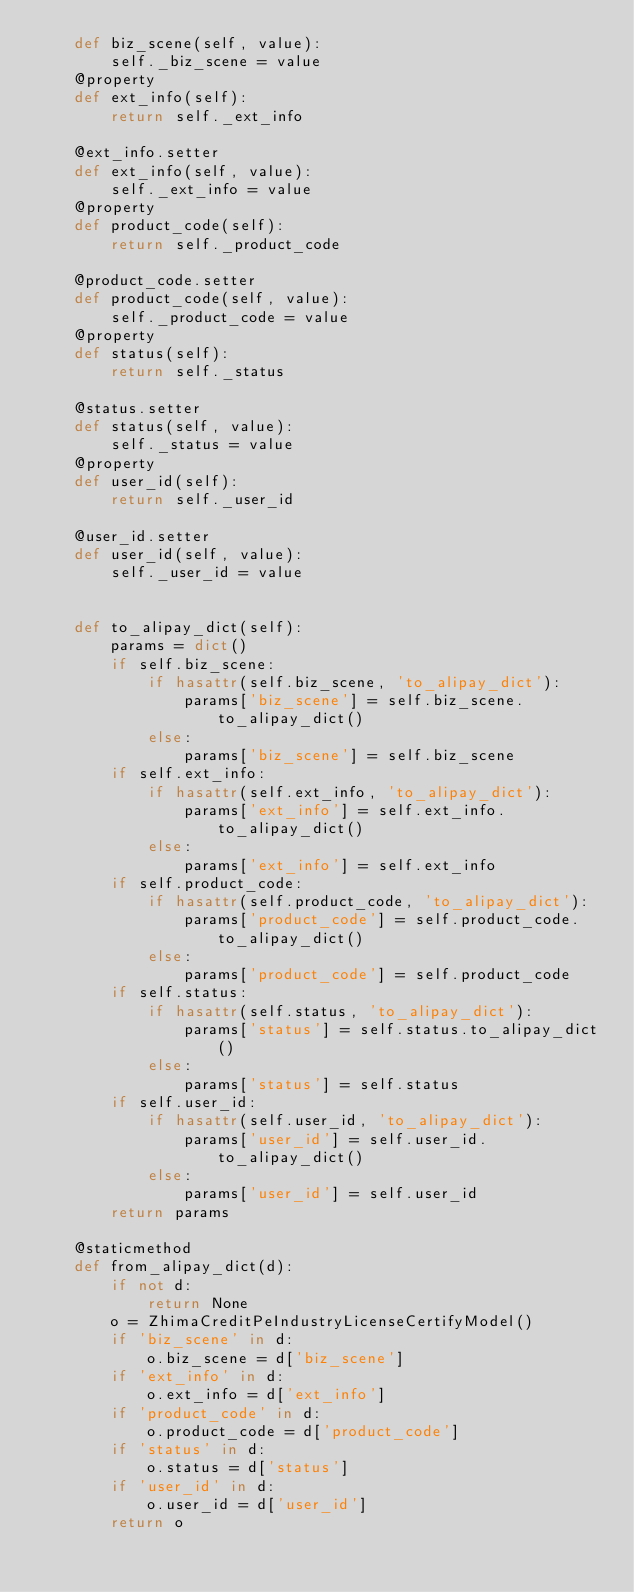Convert code to text. <code><loc_0><loc_0><loc_500><loc_500><_Python_>    def biz_scene(self, value):
        self._biz_scene = value
    @property
    def ext_info(self):
        return self._ext_info

    @ext_info.setter
    def ext_info(self, value):
        self._ext_info = value
    @property
    def product_code(self):
        return self._product_code

    @product_code.setter
    def product_code(self, value):
        self._product_code = value
    @property
    def status(self):
        return self._status

    @status.setter
    def status(self, value):
        self._status = value
    @property
    def user_id(self):
        return self._user_id

    @user_id.setter
    def user_id(self, value):
        self._user_id = value


    def to_alipay_dict(self):
        params = dict()
        if self.biz_scene:
            if hasattr(self.biz_scene, 'to_alipay_dict'):
                params['biz_scene'] = self.biz_scene.to_alipay_dict()
            else:
                params['biz_scene'] = self.biz_scene
        if self.ext_info:
            if hasattr(self.ext_info, 'to_alipay_dict'):
                params['ext_info'] = self.ext_info.to_alipay_dict()
            else:
                params['ext_info'] = self.ext_info
        if self.product_code:
            if hasattr(self.product_code, 'to_alipay_dict'):
                params['product_code'] = self.product_code.to_alipay_dict()
            else:
                params['product_code'] = self.product_code
        if self.status:
            if hasattr(self.status, 'to_alipay_dict'):
                params['status'] = self.status.to_alipay_dict()
            else:
                params['status'] = self.status
        if self.user_id:
            if hasattr(self.user_id, 'to_alipay_dict'):
                params['user_id'] = self.user_id.to_alipay_dict()
            else:
                params['user_id'] = self.user_id
        return params

    @staticmethod
    def from_alipay_dict(d):
        if not d:
            return None
        o = ZhimaCreditPeIndustryLicenseCertifyModel()
        if 'biz_scene' in d:
            o.biz_scene = d['biz_scene']
        if 'ext_info' in d:
            o.ext_info = d['ext_info']
        if 'product_code' in d:
            o.product_code = d['product_code']
        if 'status' in d:
            o.status = d['status']
        if 'user_id' in d:
            o.user_id = d['user_id']
        return o


</code> 